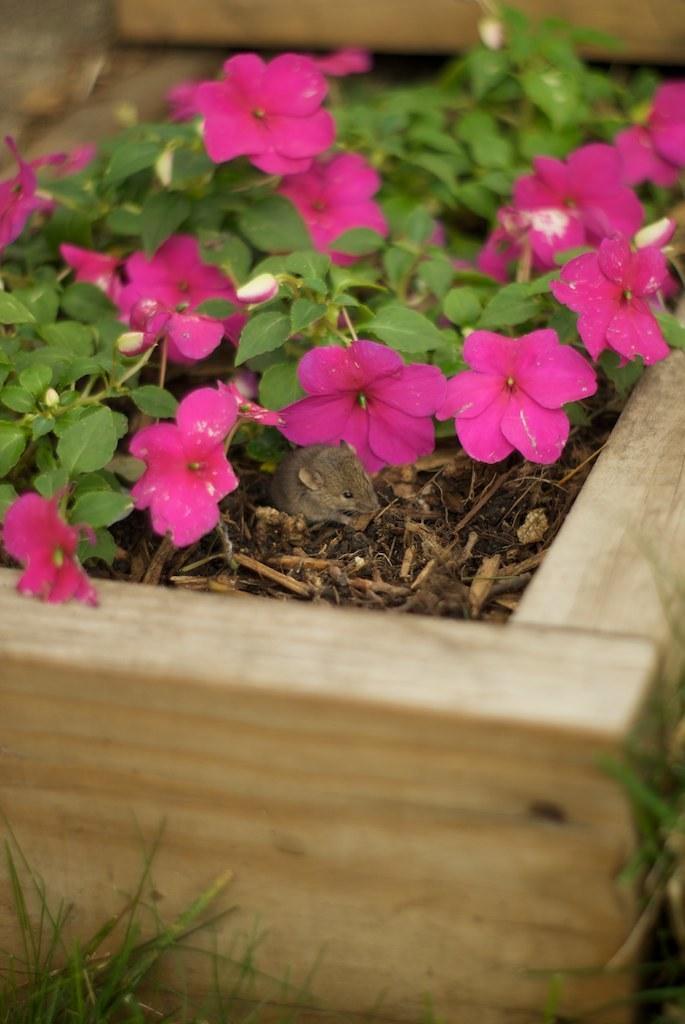Can you describe this image briefly? In this image we can see flowers, leaves, twigs and other objects. At the bottom of the image there is a grass and a wooden object. 